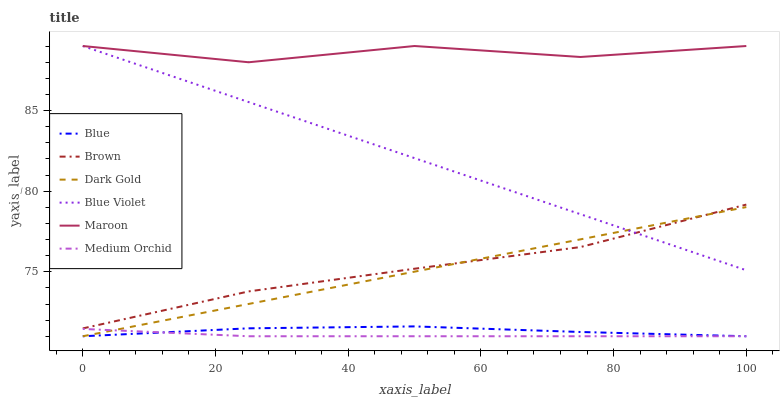Does Medium Orchid have the minimum area under the curve?
Answer yes or no. Yes. Does Maroon have the maximum area under the curve?
Answer yes or no. Yes. Does Brown have the minimum area under the curve?
Answer yes or no. No. Does Brown have the maximum area under the curve?
Answer yes or no. No. Is Blue Violet the smoothest?
Answer yes or no. Yes. Is Maroon the roughest?
Answer yes or no. Yes. Is Brown the smoothest?
Answer yes or no. No. Is Brown the roughest?
Answer yes or no. No. Does Blue have the lowest value?
Answer yes or no. Yes. Does Brown have the lowest value?
Answer yes or no. No. Does Blue Violet have the highest value?
Answer yes or no. Yes. Does Brown have the highest value?
Answer yes or no. No. Is Blue less than Brown?
Answer yes or no. Yes. Is Maroon greater than Blue?
Answer yes or no. Yes. Does Dark Gold intersect Medium Orchid?
Answer yes or no. Yes. Is Dark Gold less than Medium Orchid?
Answer yes or no. No. Is Dark Gold greater than Medium Orchid?
Answer yes or no. No. Does Blue intersect Brown?
Answer yes or no. No. 